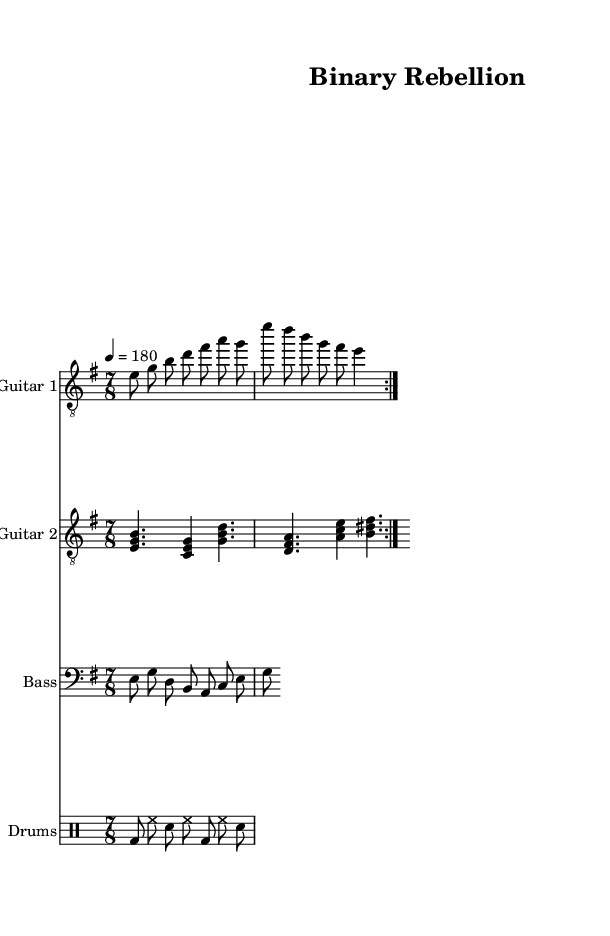What is the key signature of this music? The key signature is indicated by the 'key' declaration in the global variable, which shows 'e minor', meaning it has one sharp (F#).
Answer: E minor What is the time signature of this piece? The time signature is evidenced by the 'time' declaration in the global variable, which shows '7/8', indicating seven eighth notes per measure.
Answer: 7/8 What is the tempo marking of the piece? The tempo is determined by the 'tempo' declaration in the global variable, which states '4 = 180', meaning there are 180 beats per minute with a quarter note as the beat unit.
Answer: 180 How many measures are in the electric guitar's first section? The electric guitar part has two repeated sections indicated by 'volta', each containing two measures, leading to a total of four measures in the first section.
Answer: 4 What is the primary dynamic of the bass guitar part? The bass guitar plays consistently with eighth notes, and since there is no dynamic marking present, it is typically assumed to be played at a moderate level unless specified otherwise.
Answer: Moderate Which instrument has the clef "treble_8"? The treble clef notation 'treble_8' is seen for both electric guitar staves, indicating these guitars play in a higher pitch range suitable for their part.
Answer: Electric Guitar What lyrical theme is explored in the song? The lyrics mention "Bits and bytes in rebellion" and "algorithmic anarchy reigns," pointing towards a theme that blends technology with rebellion typical of punk music's ethos.
Answer: Technology and rebellion 